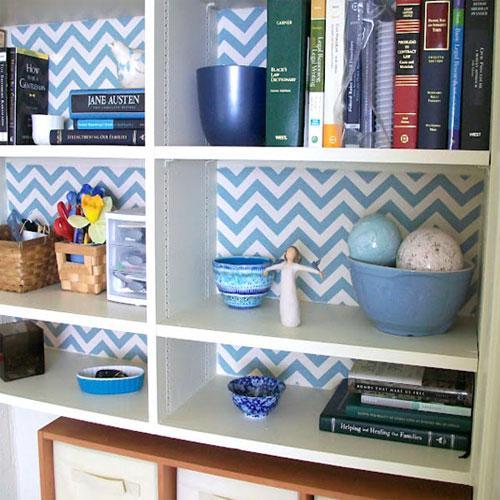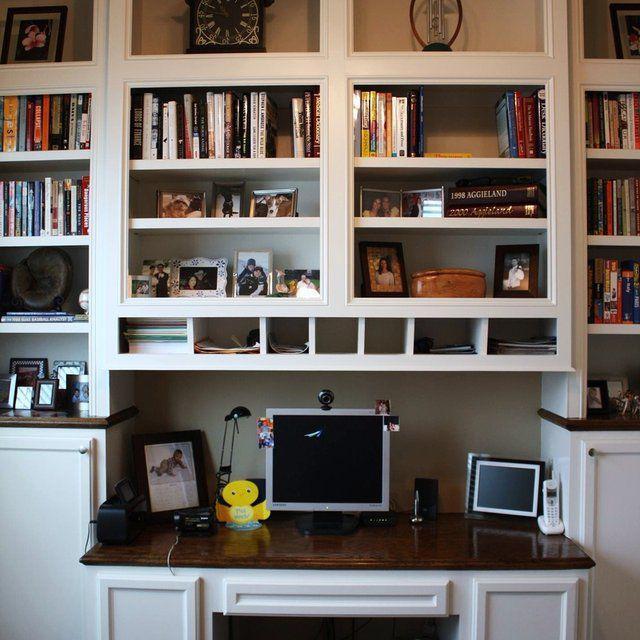The first image is the image on the left, the second image is the image on the right. Given the left and right images, does the statement "In one image, a shelf unit that is two shelves wide and at least three shelves tall is open at the back to a wall with a decorative overall design." hold true? Answer yes or no. Yes. The first image is the image on the left, the second image is the image on the right. Evaluate the accuracy of this statement regarding the images: "One of the bookcases as a patterned back wall.". Is it true? Answer yes or no. Yes. 